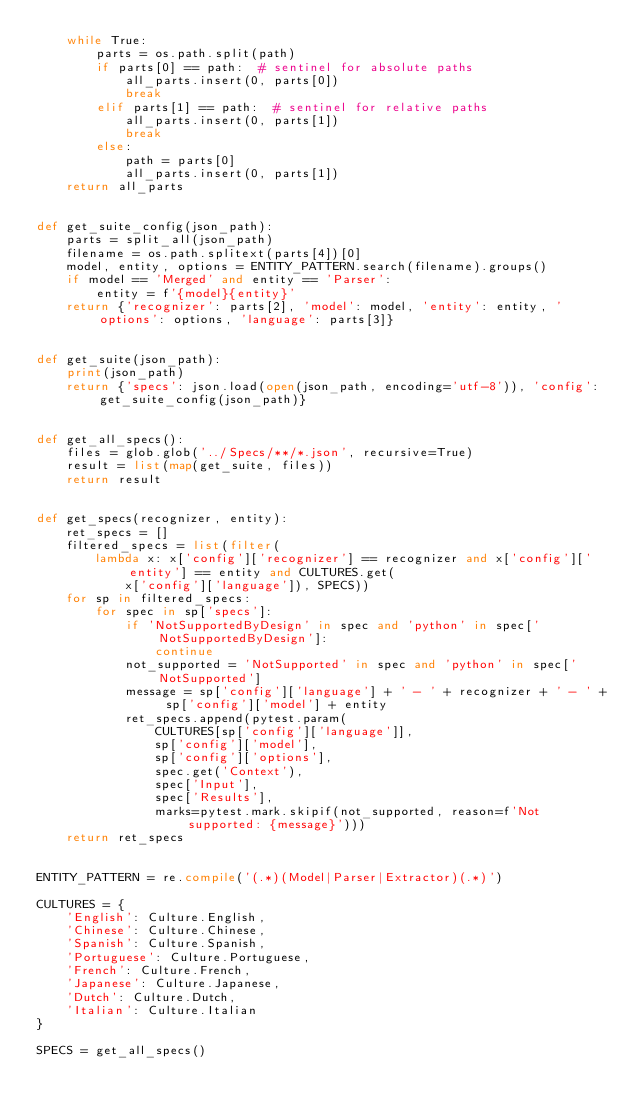<code> <loc_0><loc_0><loc_500><loc_500><_Python_>    while True:
        parts = os.path.split(path)
        if parts[0] == path:  # sentinel for absolute paths
            all_parts.insert(0, parts[0])
            break
        elif parts[1] == path:  # sentinel for relative paths
            all_parts.insert(0, parts[1])
            break
        else:
            path = parts[0]
            all_parts.insert(0, parts[1])
    return all_parts


def get_suite_config(json_path):
    parts = split_all(json_path)
    filename = os.path.splitext(parts[4])[0]
    model, entity, options = ENTITY_PATTERN.search(filename).groups()
    if model == 'Merged' and entity == 'Parser':
        entity = f'{model}{entity}'
    return {'recognizer': parts[2], 'model': model, 'entity': entity, 'options': options, 'language': parts[3]}


def get_suite(json_path):
    print(json_path)
    return {'specs': json.load(open(json_path, encoding='utf-8')), 'config': get_suite_config(json_path)}


def get_all_specs():
    files = glob.glob('../Specs/**/*.json', recursive=True)
    result = list(map(get_suite, files))
    return result


def get_specs(recognizer, entity):
    ret_specs = []
    filtered_specs = list(filter(
        lambda x: x['config']['recognizer'] == recognizer and x['config']['entity'] == entity and CULTURES.get(
            x['config']['language']), SPECS))
    for sp in filtered_specs:
        for spec in sp['specs']:
            if 'NotSupportedByDesign' in spec and 'python' in spec['NotSupportedByDesign']:
                continue
            not_supported = 'NotSupported' in spec and 'python' in spec['NotSupported']
            message = sp['config']['language'] + ' - ' + recognizer + ' - ' + sp['config']['model'] + entity
            ret_specs.append(pytest.param(
                CULTURES[sp['config']['language']],
                sp['config']['model'],
                sp['config']['options'],
                spec.get('Context'),
                spec['Input'],
                spec['Results'],
                marks=pytest.mark.skipif(not_supported, reason=f'Not supported: {message}')))
    return ret_specs


ENTITY_PATTERN = re.compile('(.*)(Model|Parser|Extractor)(.*)')

CULTURES = {
    'English': Culture.English,
    'Chinese': Culture.Chinese,
    'Spanish': Culture.Spanish,
    'Portuguese': Culture.Portuguese,
    'French': Culture.French,
    'Japanese': Culture.Japanese,
    'Dutch': Culture.Dutch,
    'Italian': Culture.Italian
}

SPECS = get_all_specs()
</code> 